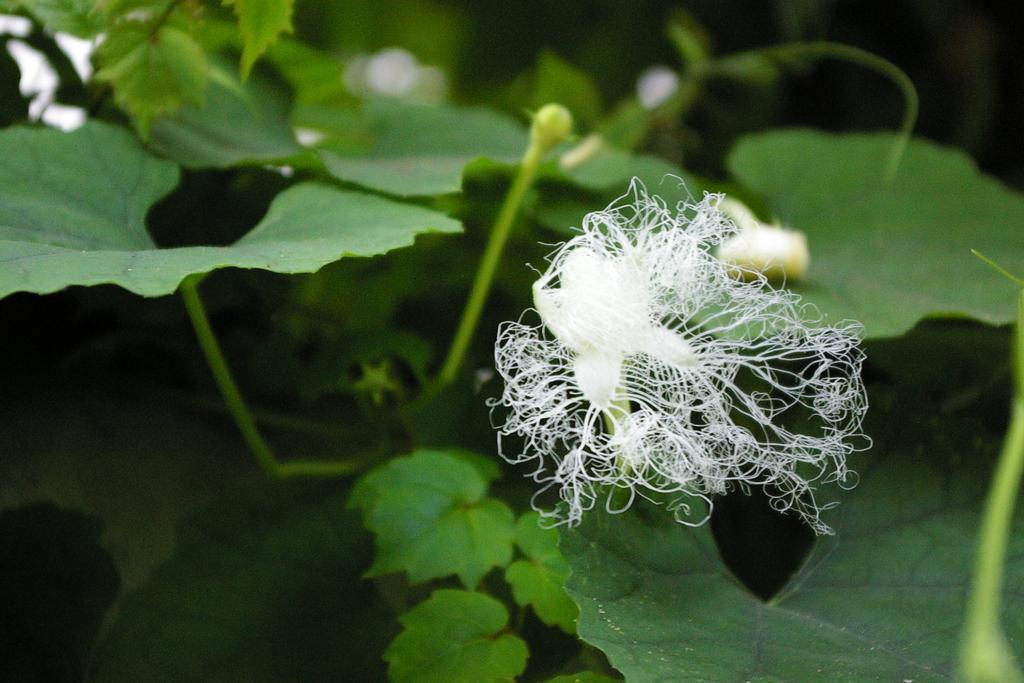Can you describe this image briefly? In this image we can see flowers and buds to a plant. In the background, we can see some plants. 